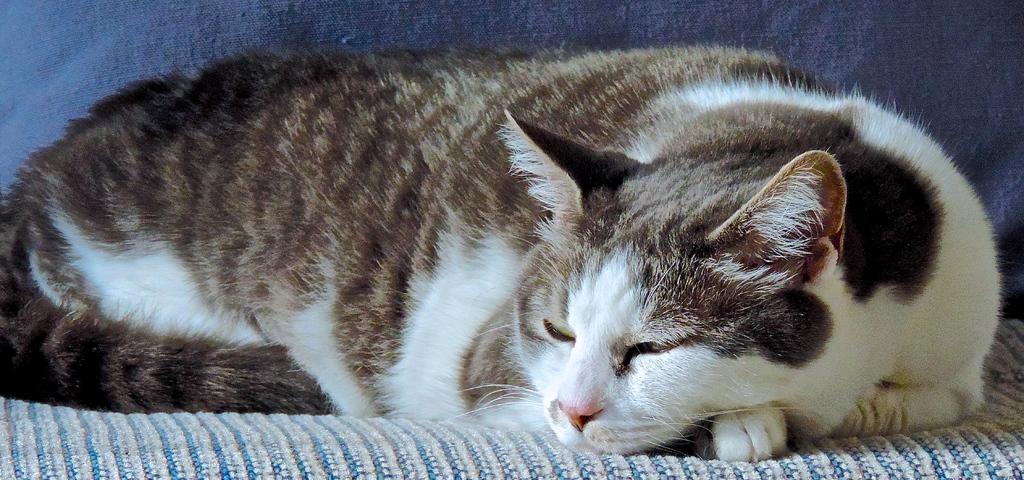How would you summarize this image in a sentence or two? It is a zoomed in picture of a cat present on the sofa. 